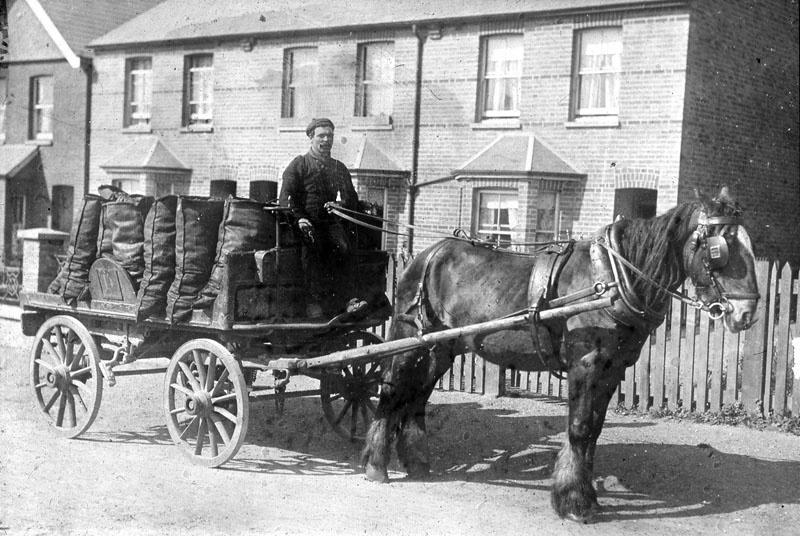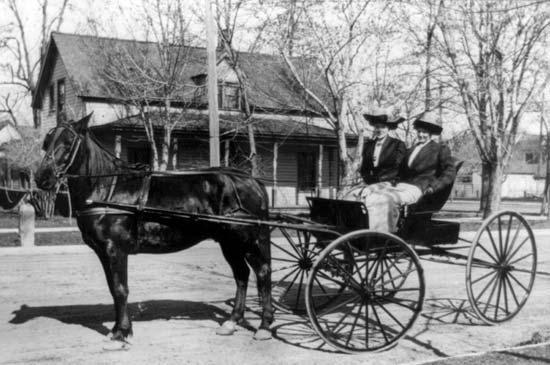The first image is the image on the left, the second image is the image on the right. Assess this claim about the two images: "Both images are vintage photos of a carriage.". Correct or not? Answer yes or no. Yes. The first image is the image on the left, the second image is the image on the right. For the images shown, is this caption "There is no color in either image." true? Answer yes or no. Yes. 